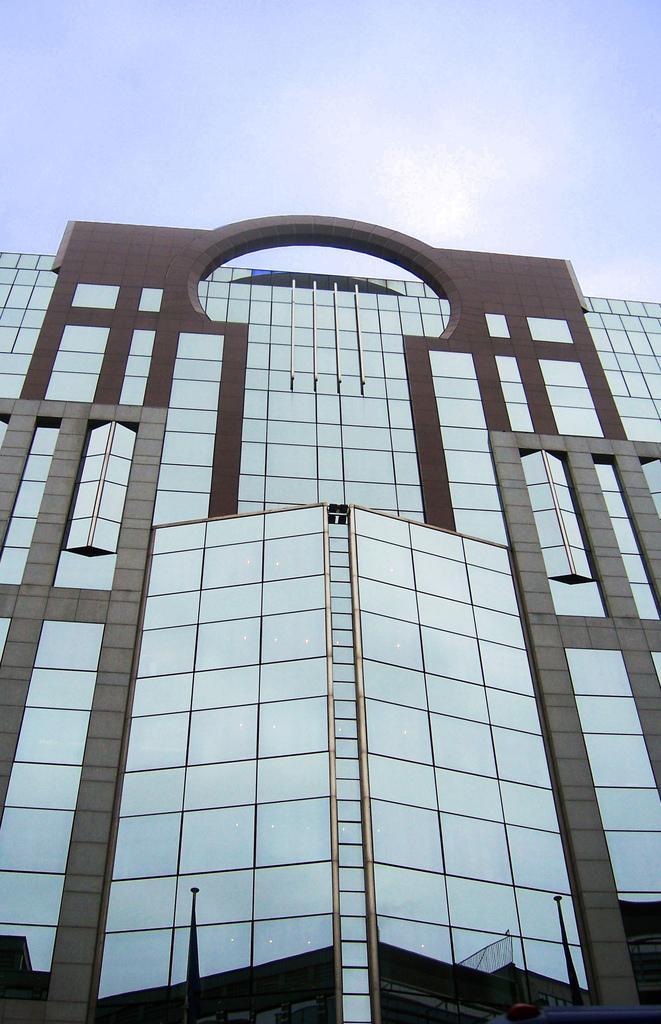Describe this image in one or two sentences. In this image we can see a building. In the background we can see sky. 